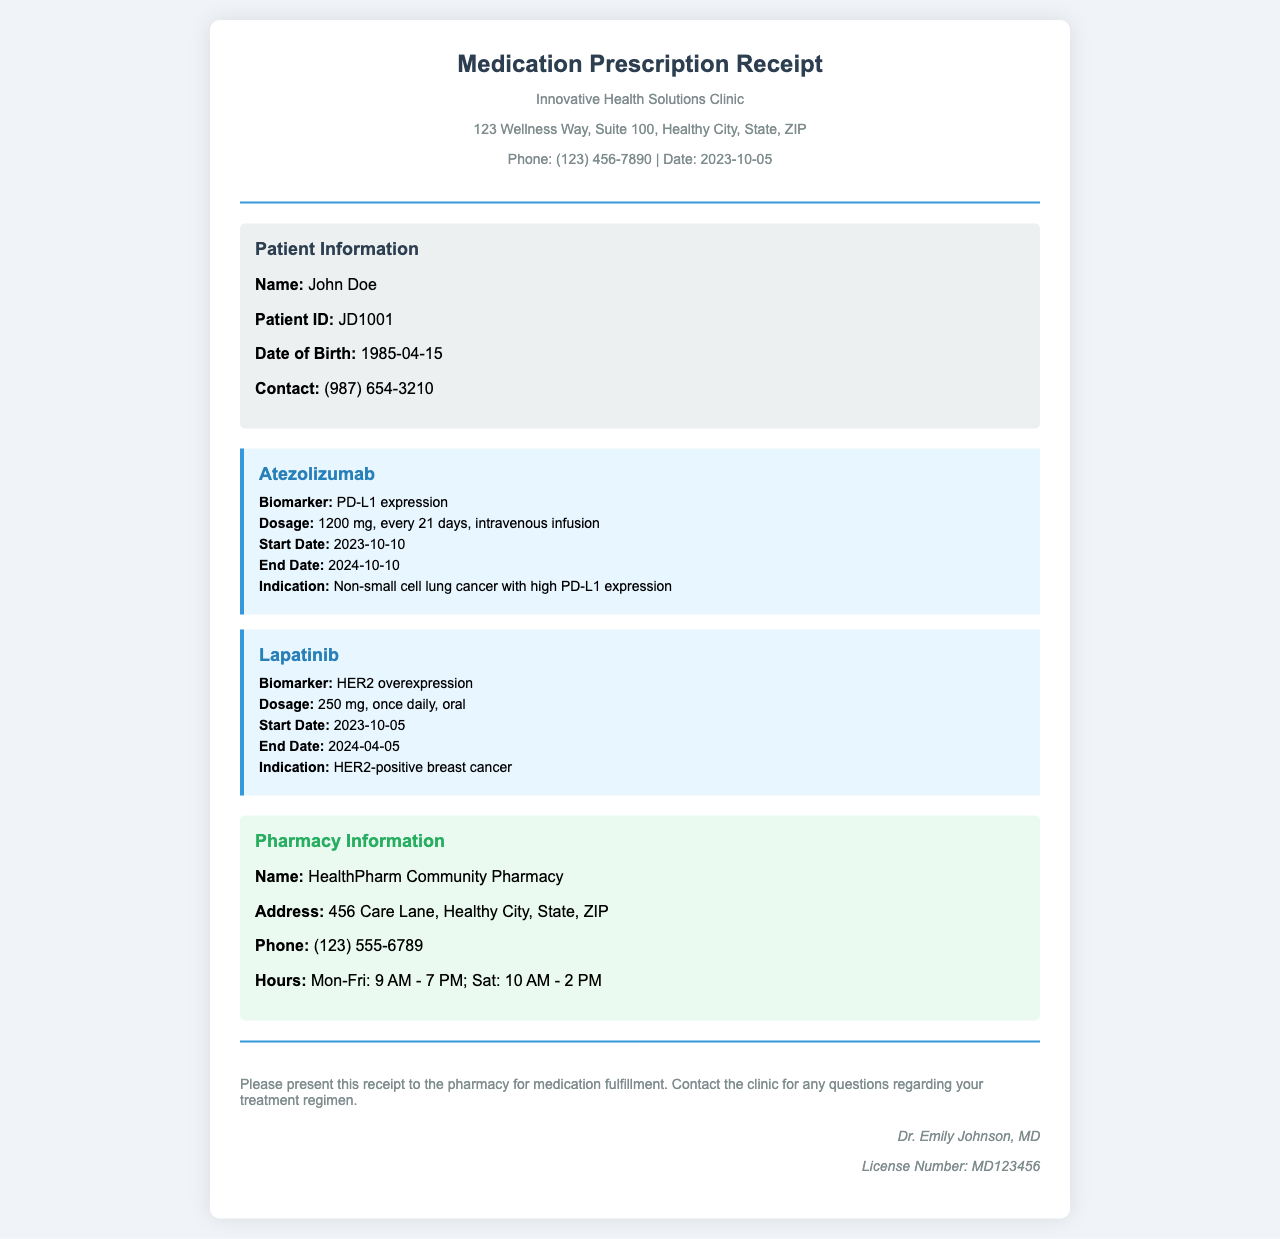What is the name of the patient? The patient's name is located in the patient information section of the document.
Answer: John Doe What is the dosage of Atezolizumab? The dosage is explicitly mentioned in the medication section for Atezolizumab.
Answer: 1200 mg, every 21 days, intravenous infusion What is the start date for Lapatinib? The start date is provided in the medication section under Lapatinib.
Answer: 2023-10-05 What is the indication for Atezolizumab? The indication is mentioned under the Atezolizumab medication details.
Answer: Non-small cell lung cancer with high PD-L1 expression What is the address of the pharmacy? The pharmacy's address is specified in the pharmacy information section of the document.
Answer: 456 Care Lane, Healthy City, State, ZIP How long is the treatment for Lapatinib? The treatment duration can be calculated from the start and end dates for Lapatinib.
Answer: 6 months Who issued this prescription? The doctor's name is provided in the footer of the document.
Answer: Dr. Emily Johnson What is the license number of the prescribing doctor? The license number is indicated in the signature area of the document.
Answer: MD123456 What type of document is this? This document serves as a receipt for medication prescriptions.
Answer: Medication Prescription Receipt 